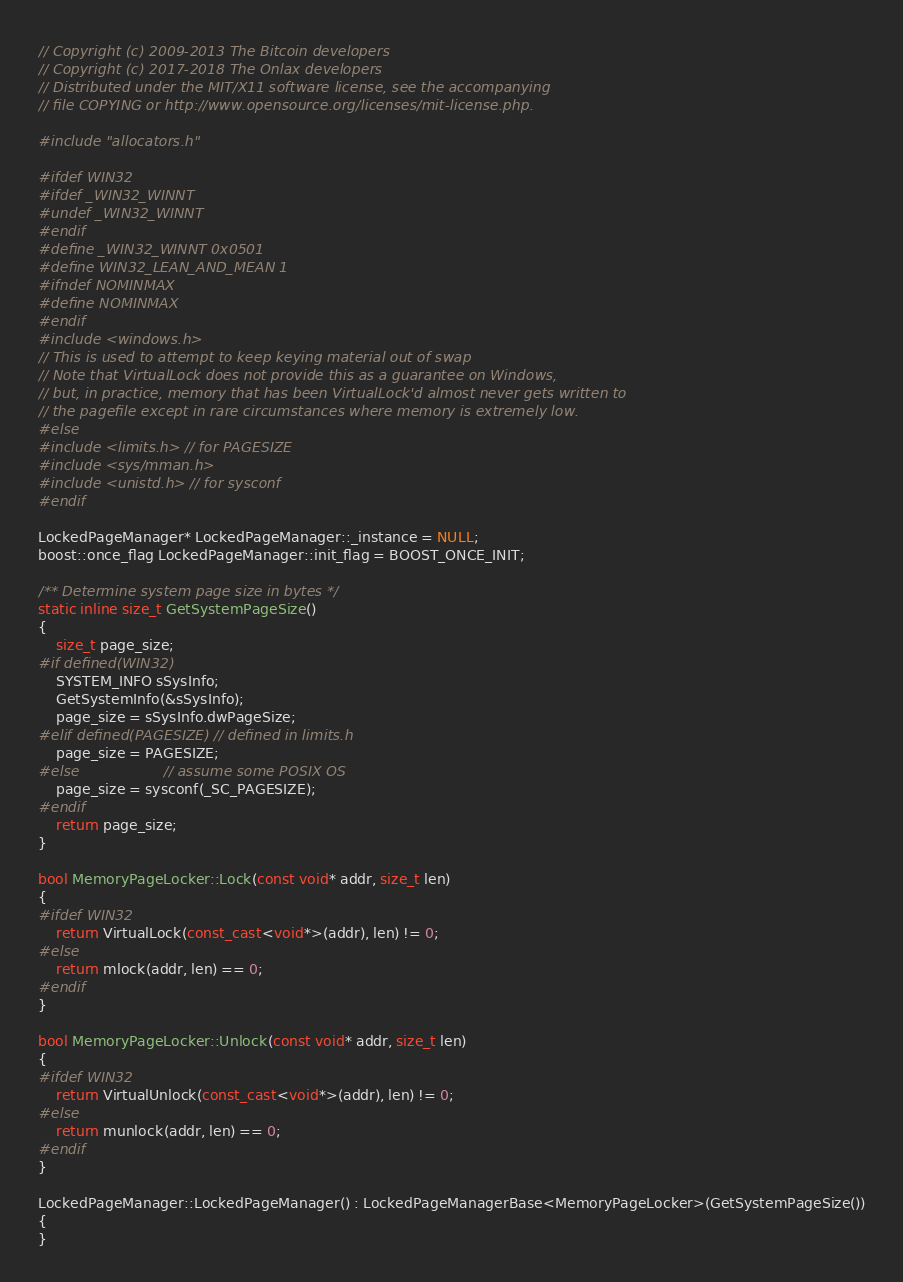Convert code to text. <code><loc_0><loc_0><loc_500><loc_500><_C++_>// Copyright (c) 2009-2013 The Bitcoin developers
// Copyright (c) 2017-2018 The Onlax developers
// Distributed under the MIT/X11 software license, see the accompanying
// file COPYING or http://www.opensource.org/licenses/mit-license.php.

#include "allocators.h"

#ifdef WIN32
#ifdef _WIN32_WINNT
#undef _WIN32_WINNT
#endif
#define _WIN32_WINNT 0x0501
#define WIN32_LEAN_AND_MEAN 1
#ifndef NOMINMAX
#define NOMINMAX
#endif
#include <windows.h>
// This is used to attempt to keep keying material out of swap
// Note that VirtualLock does not provide this as a guarantee on Windows,
// but, in practice, memory that has been VirtualLock'd almost never gets written to
// the pagefile except in rare circumstances where memory is extremely low.
#else
#include <limits.h> // for PAGESIZE
#include <sys/mman.h>
#include <unistd.h> // for sysconf
#endif

LockedPageManager* LockedPageManager::_instance = NULL;
boost::once_flag LockedPageManager::init_flag = BOOST_ONCE_INIT;

/** Determine system page size in bytes */
static inline size_t GetSystemPageSize()
{
    size_t page_size;
#if defined(WIN32)
    SYSTEM_INFO sSysInfo;
    GetSystemInfo(&sSysInfo);
    page_size = sSysInfo.dwPageSize;
#elif defined(PAGESIZE) // defined in limits.h
    page_size = PAGESIZE;
#else                   // assume some POSIX OS
    page_size = sysconf(_SC_PAGESIZE);
#endif
    return page_size;
}

bool MemoryPageLocker::Lock(const void* addr, size_t len)
{
#ifdef WIN32
    return VirtualLock(const_cast<void*>(addr), len) != 0;
#else
    return mlock(addr, len) == 0;
#endif
}

bool MemoryPageLocker::Unlock(const void* addr, size_t len)
{
#ifdef WIN32
    return VirtualUnlock(const_cast<void*>(addr), len) != 0;
#else
    return munlock(addr, len) == 0;
#endif
}

LockedPageManager::LockedPageManager() : LockedPageManagerBase<MemoryPageLocker>(GetSystemPageSize())
{
}
</code> 